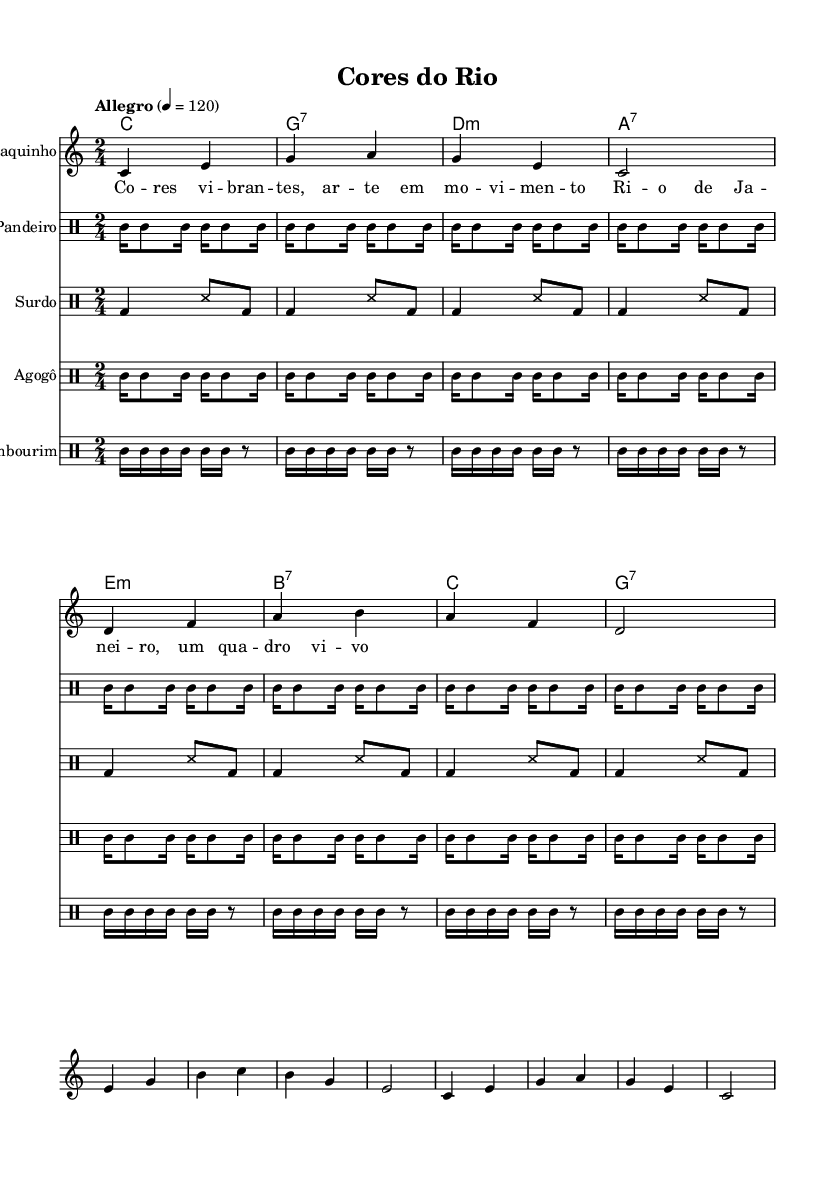What is the key signature of this music? The key signature indicates that the music is in C major, which has no sharps or flats. This can be seen at the beginning of the score.
Answer: C major What is the time signature of the piece? The time signature is 2/4, as indicated at the beginning of the score. This means there are 2 beats per measure, with each beat being a quarter note.
Answer: 2/4 What is the tempo marking of the piece? The tempo marking is "Allegro," which indicates a lively tempo. The metronome marking of 120 beats per minute is written next to it, specifying the speed.
Answer: Allegro How many measures are played in the Cavaquinho melody before the repeat? By counting the measures in the provided Cavaquinho melody, there are 8 measures before reaching the repeat. Each line contains 4 measures, totaling 8 in two lines.
Answer: 8 Which instrument plays the provided rhythms? The rhythms indicated in the score are played by Pandeiro, Surdo, Agogô, and Tambourim as specified in the score headings. Each rhythm is associated with its respective instrument written in the score.
Answer: Pandeiro, Surdo, Agogô, Tambourim What symbolic function does the "Cores do Rio" title serve in relation to the piece? The title "Cores do Rio," translates to "Colors of Rio," and reflects the vibrant and lively character of Rio's art and culture, which is thematically represented in the samba rhythm and liveliness of the music.
Answer: Reflects vibrant Rio culture What is the primary rhythmic feature used in the pandeiro part? The primary rhythmic feature in the pandeiro part consists of patterns with alternating hits and rests, as shown in the repeated rhythmic structure, maintaining the samba style characteristic.
Answer: Alternating hits and rests 